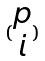Convert formula to latex. <formula><loc_0><loc_0><loc_500><loc_500>( \begin{matrix} p \\ i \end{matrix} )</formula> 